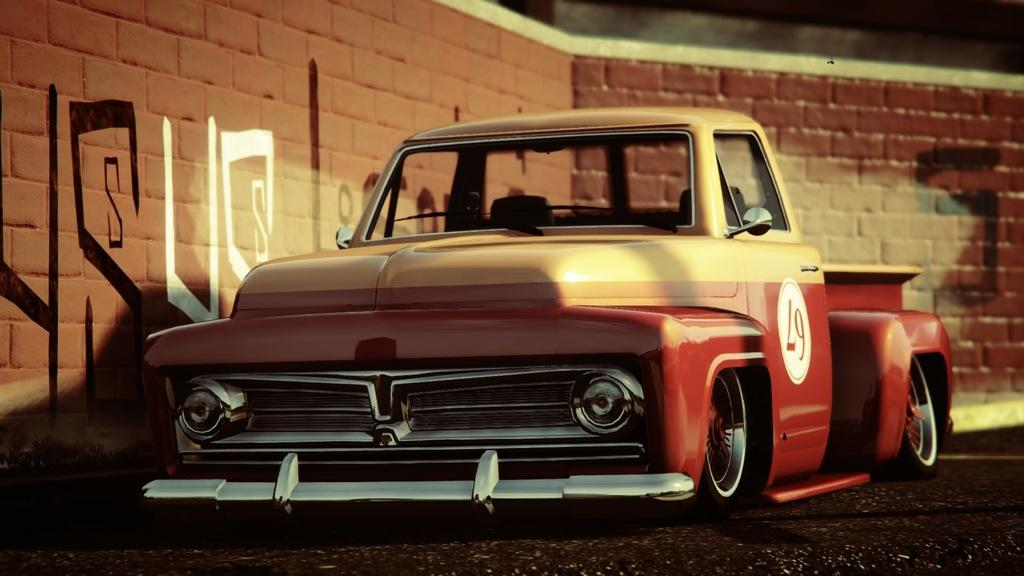What is the main subject of the image? There is a vehicle in the image. Can you describe the position of the vehicle? The vehicle is on the ground. What can be seen in the background of the image? There is a wall in the background of the image. What type of juice is being squeezed out of the balloon in the image? There is no balloon or juice present in the image; it features a vehicle on the ground with a wall in the background. 